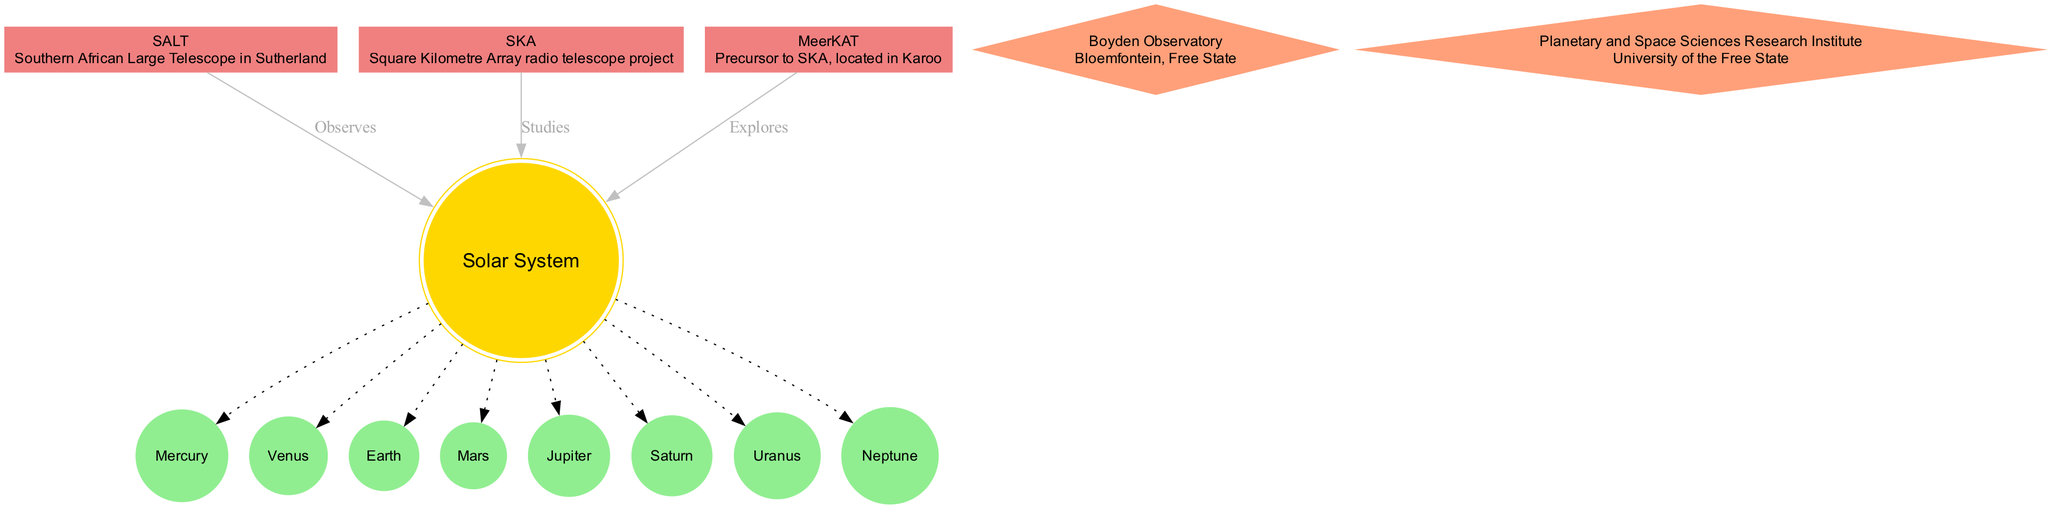What is the central node of the diagram? The central node is explicitly labeled in the diagram as "Solar System." Therefore, by referring to the center of the diagram, we can identify this node easily.
Answer: Solar System How many planets are represented in the diagram? The diagram explicitly lists eight planets surrounding the central node, which can be counted directly from the visual display of the diagram.
Answer: 8 Which telescope is located in Sutherland? The diagram clearly shows that "SALT" is associated with the description stating "Southern African Large Telescope in Sutherland," allowing us to identify this piece of information directly.
Answer: SALT What connects MeerKAT to the Solar System? The connection from MeerKAT to the Solar System is labeled "Explores," indicating that this is the nature of the connection visible in the diagram.
Answer: Explores Where is the Boyden Observatory located? The diagram lists the "Boyden Observatory" along with its location "Bloemfontein, Free State," making this information straightforward to extract from the diagram.
Answer: Bloemfontein, Free State Which project is a precursor to SKA? The diagram explicitly refers to "MeerKAT" as the precursor to SKA. This connection can be confirmed by checking the description or relationship identified in the diagram.
Answer: MeerKAT What type of contributions do SALT, SKA, and MeerKAT make to the Solar System? The diagram shows that SALT, SKA, and MeerKAT have specific contributions labeled as "Observes," "Studies," and "Explores" respectively, indicating the nature of their contributions.
Answer: Observes, Studies, Explores How many astronomy highlights are mentioned in the diagram? The diagram lists two astronomy highlights which can be counted directly: "Boyden Observatory" and "Planetary and Space Sciences Research Institute." This count leads us to the total number.
Answer: 2 What shape is the node for the Solar System? In the diagram, the Solar System is represented as a double circle shape, which is stated in the node attributes. This visual representation helps identify its shape clearly.
Answer: doublecircle 